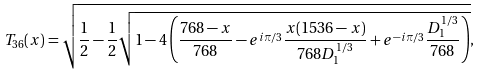Convert formula to latex. <formula><loc_0><loc_0><loc_500><loc_500>T _ { 3 6 } ( x ) = \sqrt { \frac { 1 } { 2 } - \frac { 1 } { 2 } \sqrt { 1 - 4 \left ( \frac { 7 6 8 - x } { 7 6 8 } - e ^ { i \pi / 3 } \frac { x ( 1 5 3 6 - x ) } { 7 6 8 D _ { 1 } ^ { 1 / 3 } } + e ^ { - i \pi / 3 } \frac { D _ { 1 } ^ { 1 / 3 } } { 7 6 8 } \right ) } } ,</formula> 